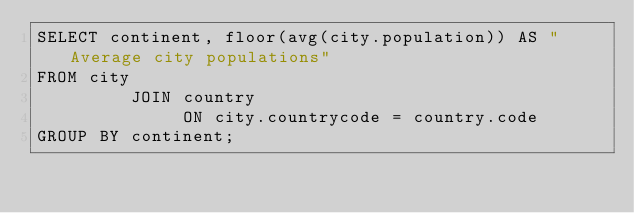<code> <loc_0><loc_0><loc_500><loc_500><_SQL_>SELECT continent, floor(avg(city.population)) AS "Average city populations"
FROM city
         JOIN country
              ON city.countrycode = country.code
GROUP BY continent;
</code> 